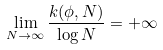<formula> <loc_0><loc_0><loc_500><loc_500>\lim _ { N \rightarrow \infty } \frac { k ( \phi , N ) } { \log N } = + \infty</formula> 